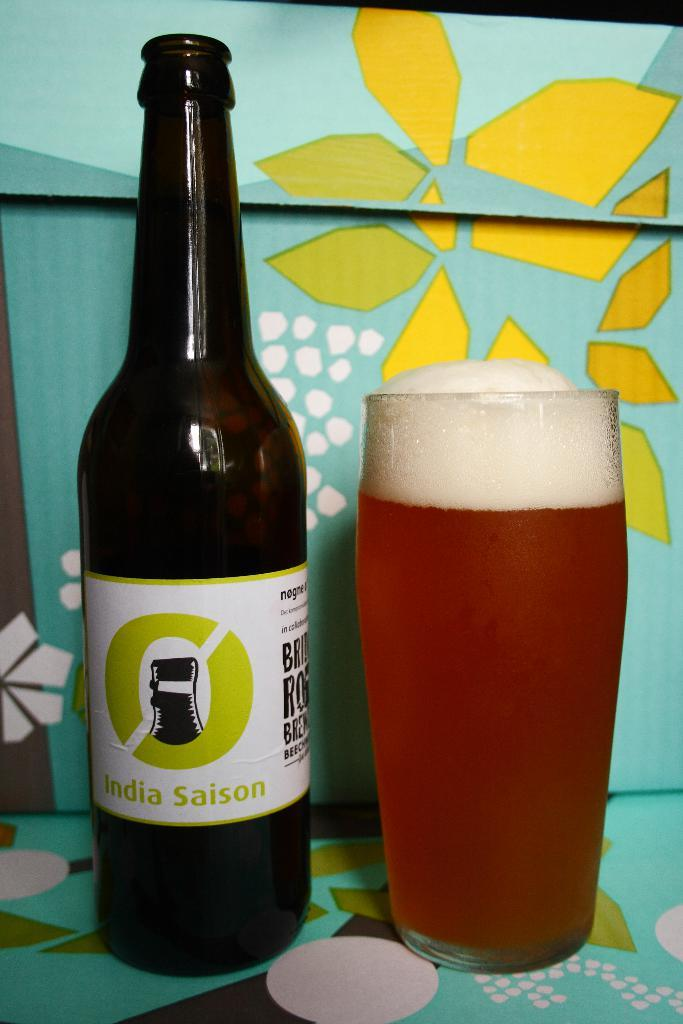What type of container is visible in the image? There is a glass bottle in the image. What else can be seen in the image that is related to beverages? There is a glass of drink in the image. What is the pattern visible in the background of the image? The background of the image has a green floral pattern. How many men are holding forks in the image? There are no men or forks present in the image. 